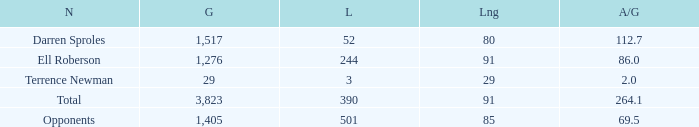When the player gained below 1,405 yards and lost over 390 yards, what's the sum of the long yards? None. 